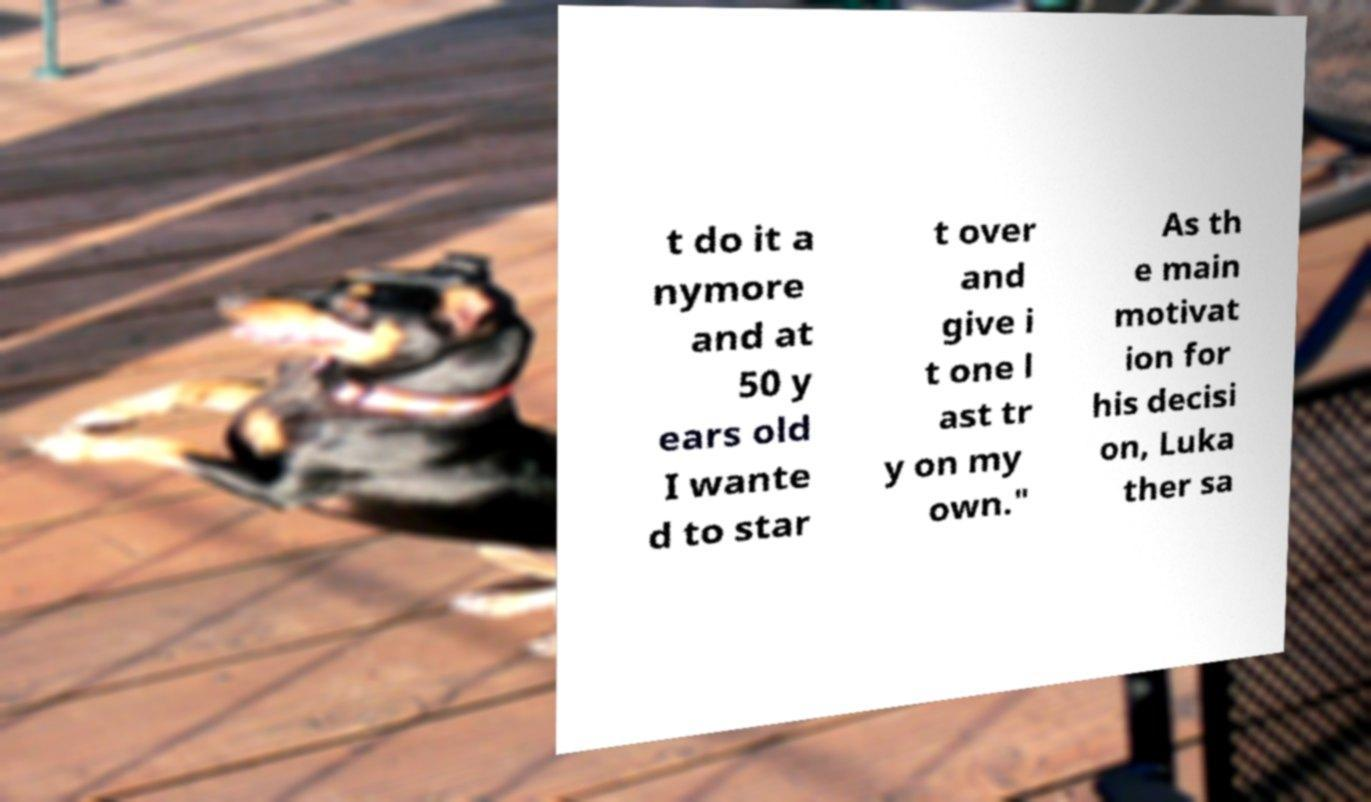Please identify and transcribe the text found in this image. t do it a nymore and at 50 y ears old I wante d to star t over and give i t one l ast tr y on my own." As th e main motivat ion for his decisi on, Luka ther sa 